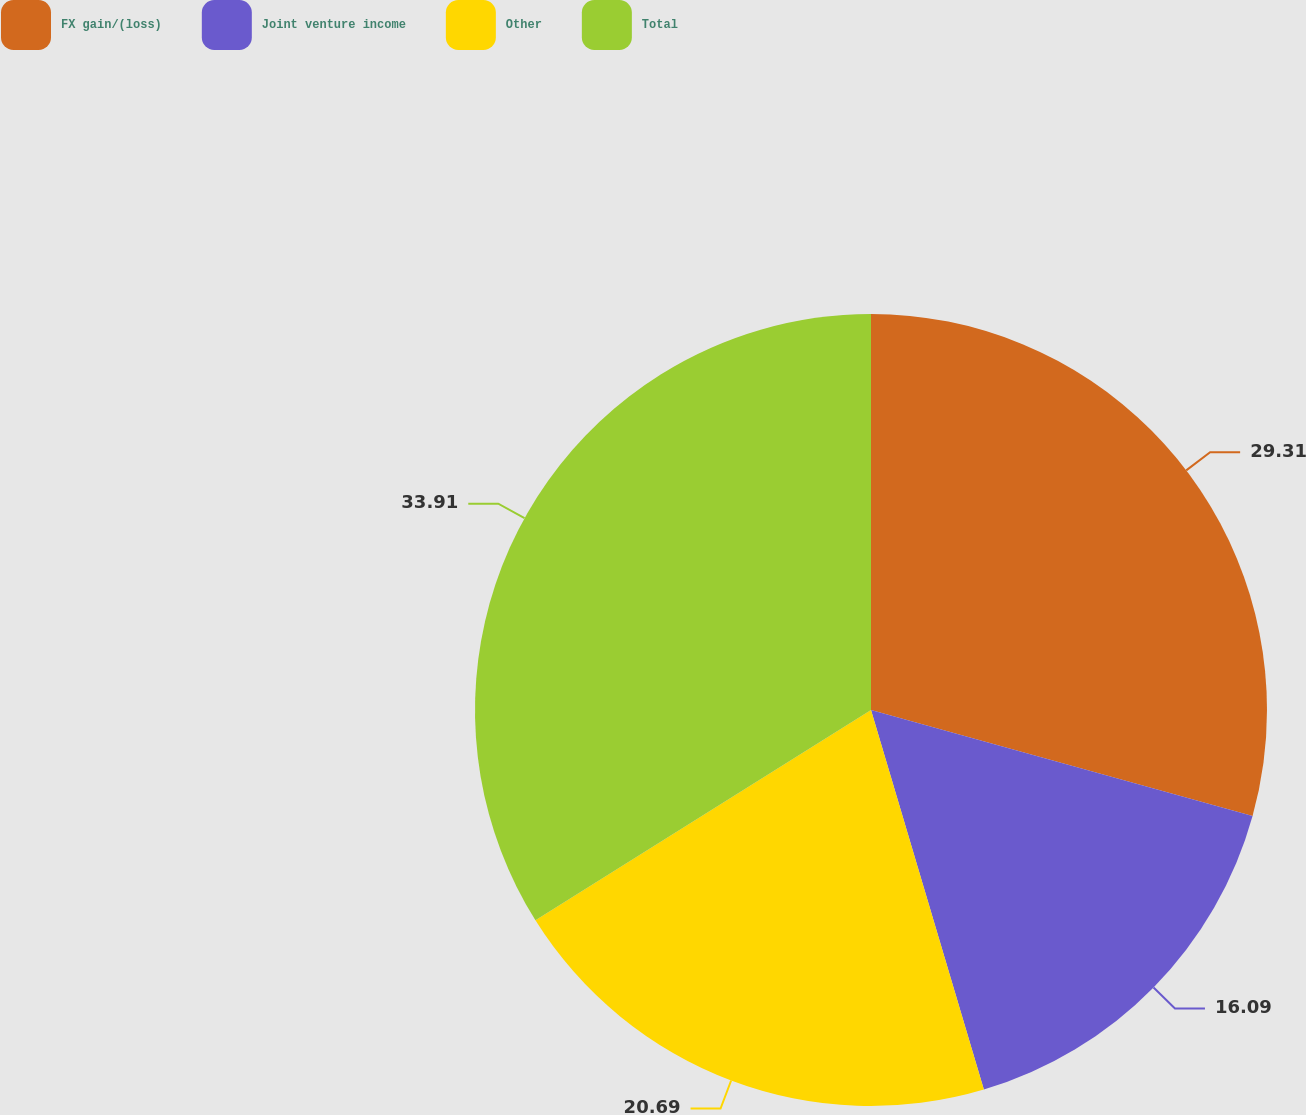Convert chart to OTSL. <chart><loc_0><loc_0><loc_500><loc_500><pie_chart><fcel>FX gain/(loss)<fcel>Joint venture income<fcel>Other<fcel>Total<nl><fcel>29.31%<fcel>16.09%<fcel>20.69%<fcel>33.91%<nl></chart> 